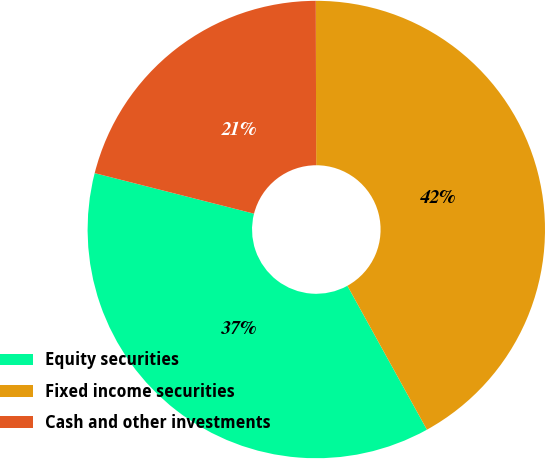Convert chart. <chart><loc_0><loc_0><loc_500><loc_500><pie_chart><fcel>Equity securities<fcel>Fixed income securities<fcel>Cash and other investments<nl><fcel>37.0%<fcel>42.0%<fcel>21.0%<nl></chart> 